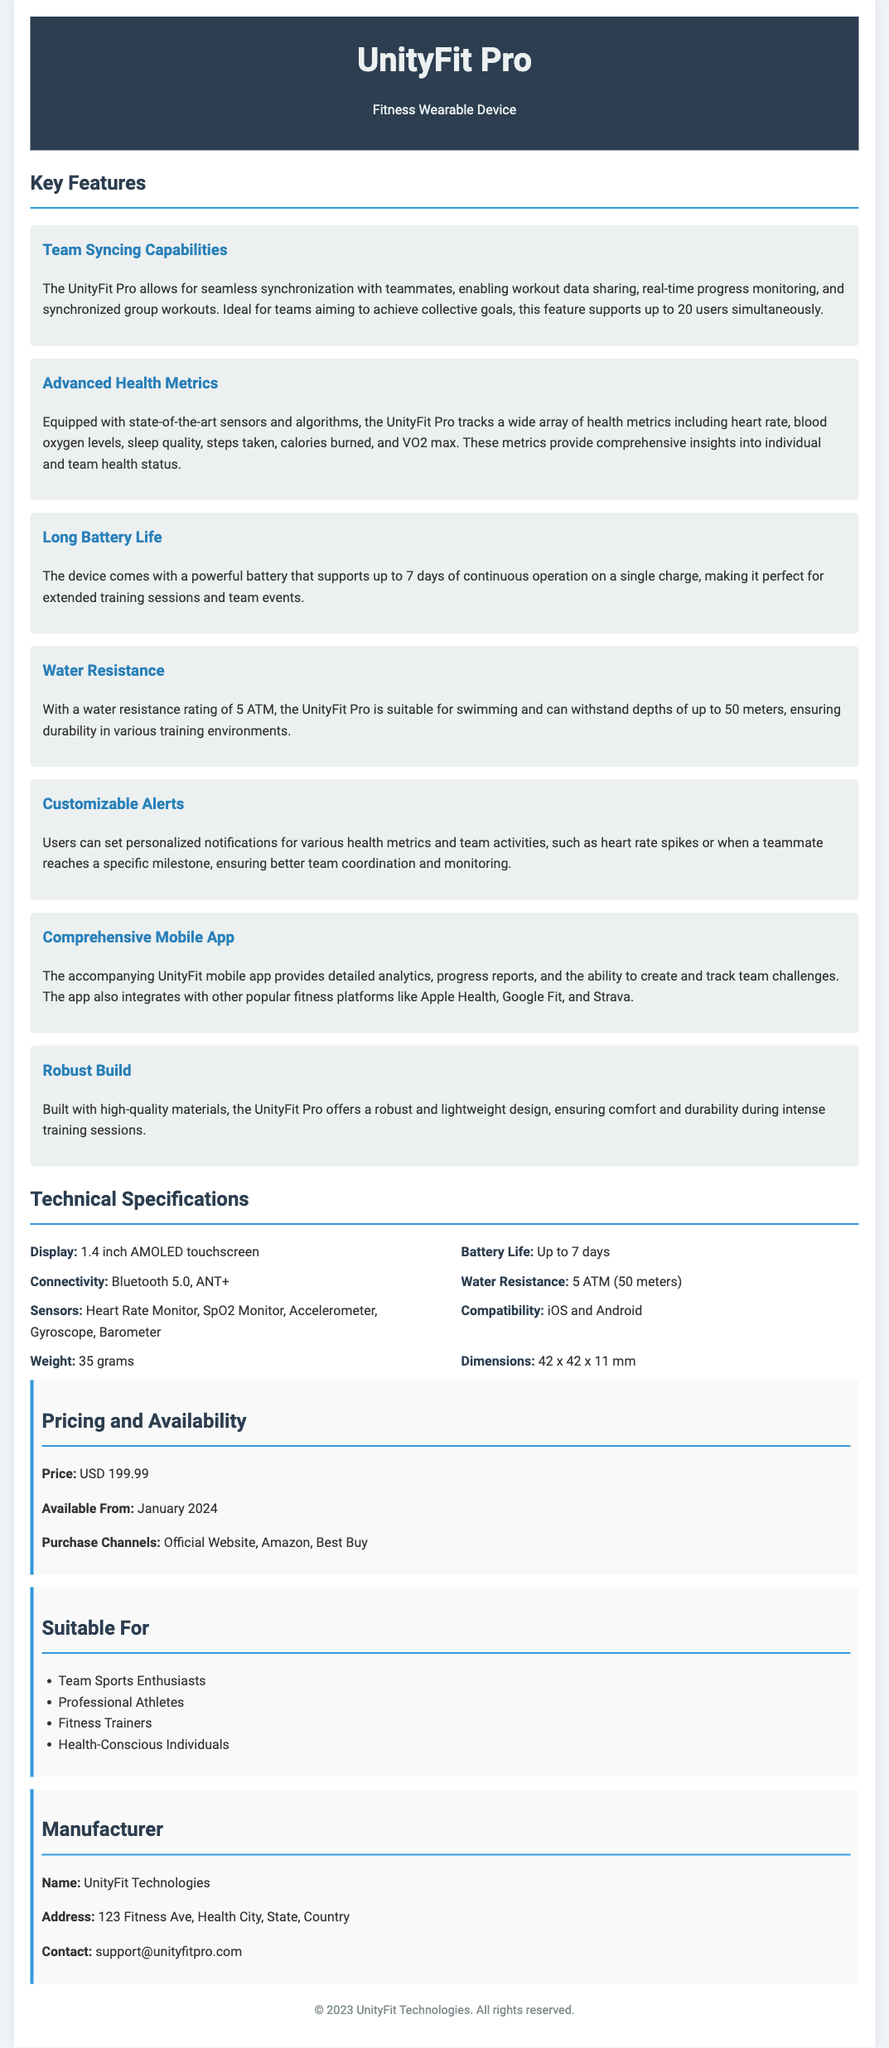What is the maximum number of users that can sync simultaneously? The document states that the UnityFit Pro supports up to 20 users simultaneously for syncing.
Answer: 20 users What health metric measures the amount of oxygen in the blood? The document mentions blood oxygen levels as one of the health metrics tracked by the device.
Answer: Blood oxygen levels What is the battery life of the UnityFit Pro? According to the specification sheet, the battery life can last up to 7 days on a single charge.
Answer: Up to 7 days What is the water resistance rating of the device? The specification states that the UnityFit Pro has a water resistance rating of 5 ATM.
Answer: 5 ATM Which mobile operating systems are compatible with the device? The document lists iOS and Android as the compatible operating systems for the UnityFit Pro.
Answer: iOS and Android What feature enhances team coordination during workouts? The ability to set personalized notifications for health metrics and team activities is highlighted as enhancing team coordination.
Answer: Customizable Alerts Who is the manufacturer of the UnityFit Pro? The document specifies that UnityFit Technologies is the manufacturer of the device.
Answer: UnityFit Technologies What is the price of the UnityFit Pro? The pricing section of the document states that the price of the device is USD 199.99.
Answer: USD 199.99 